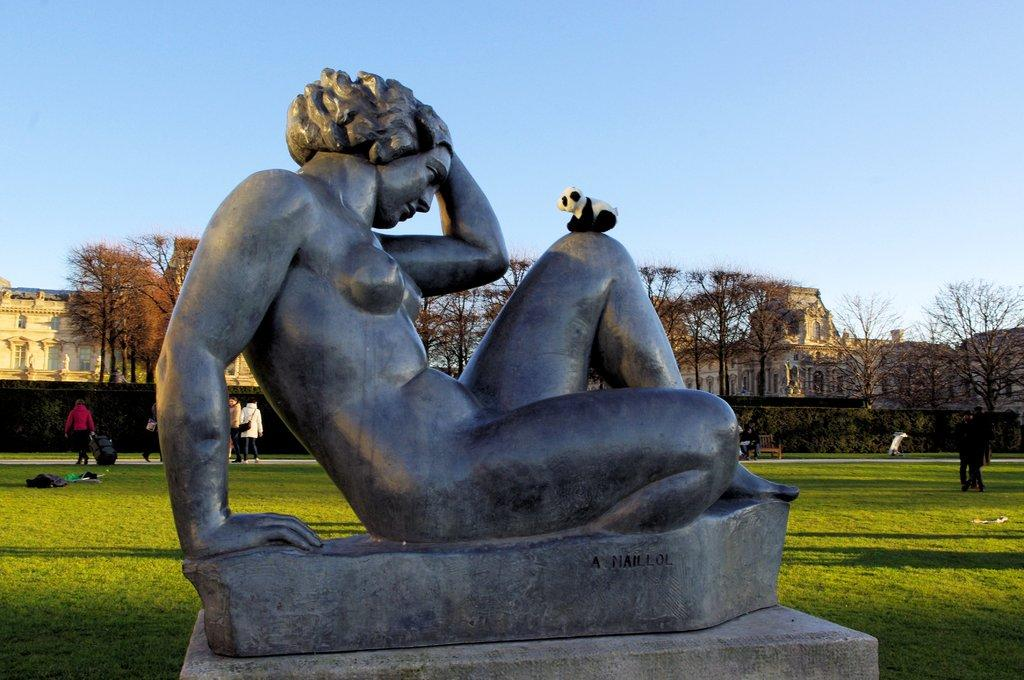What is the main subject on the platform in the image? There is a statue on a platform in the image. What else can be seen in the image besides the statue? There is a group of people on the ground behind the statue, and buildings, trees, and the sky are visible in the background of the image. What type of nerve can be seen connecting the buildings in the image? There are no visible nerves connecting the buildings in the image. 